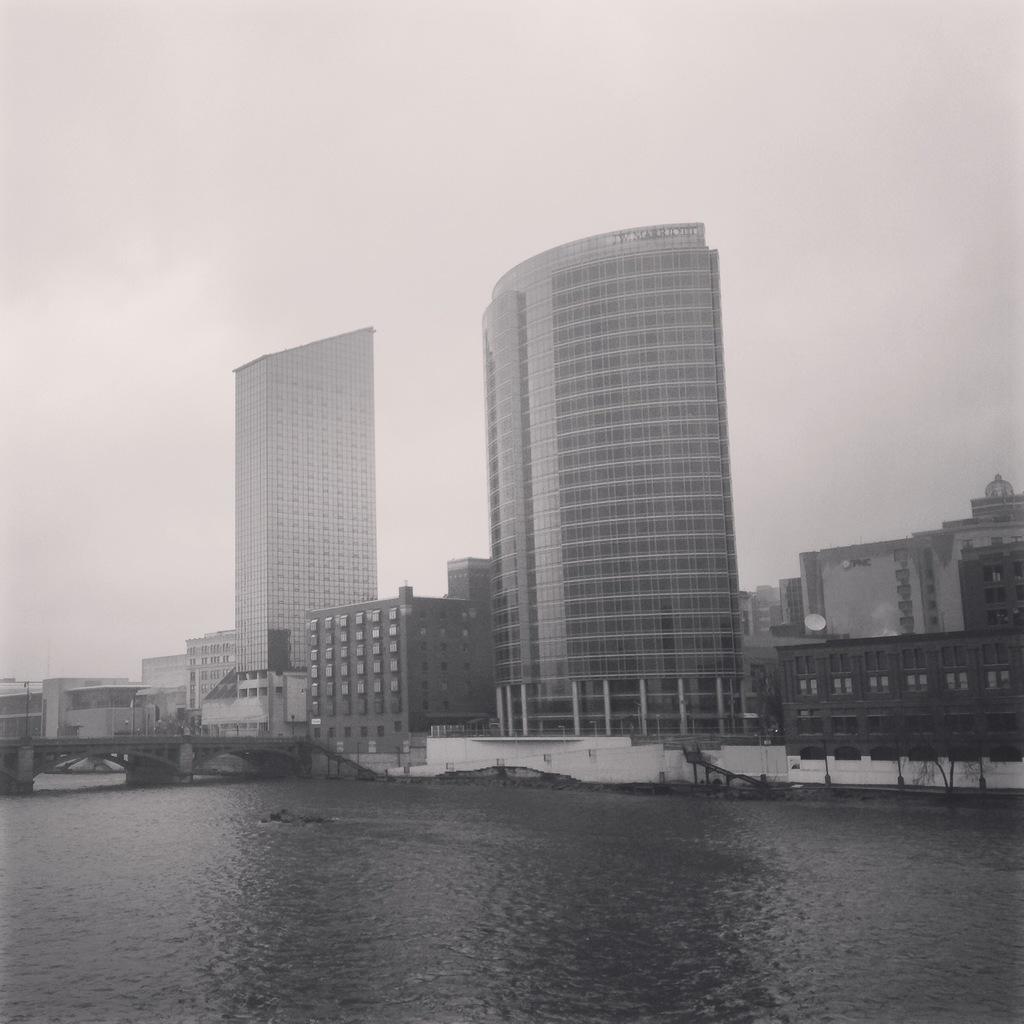Describe this image in one or two sentences. In this picture we can see buildings and skyscraper. On the bottom we can see river. On the left there is a bridge. Here we can see poles, pillars and fencing. On the top we can see sky and clouds. 